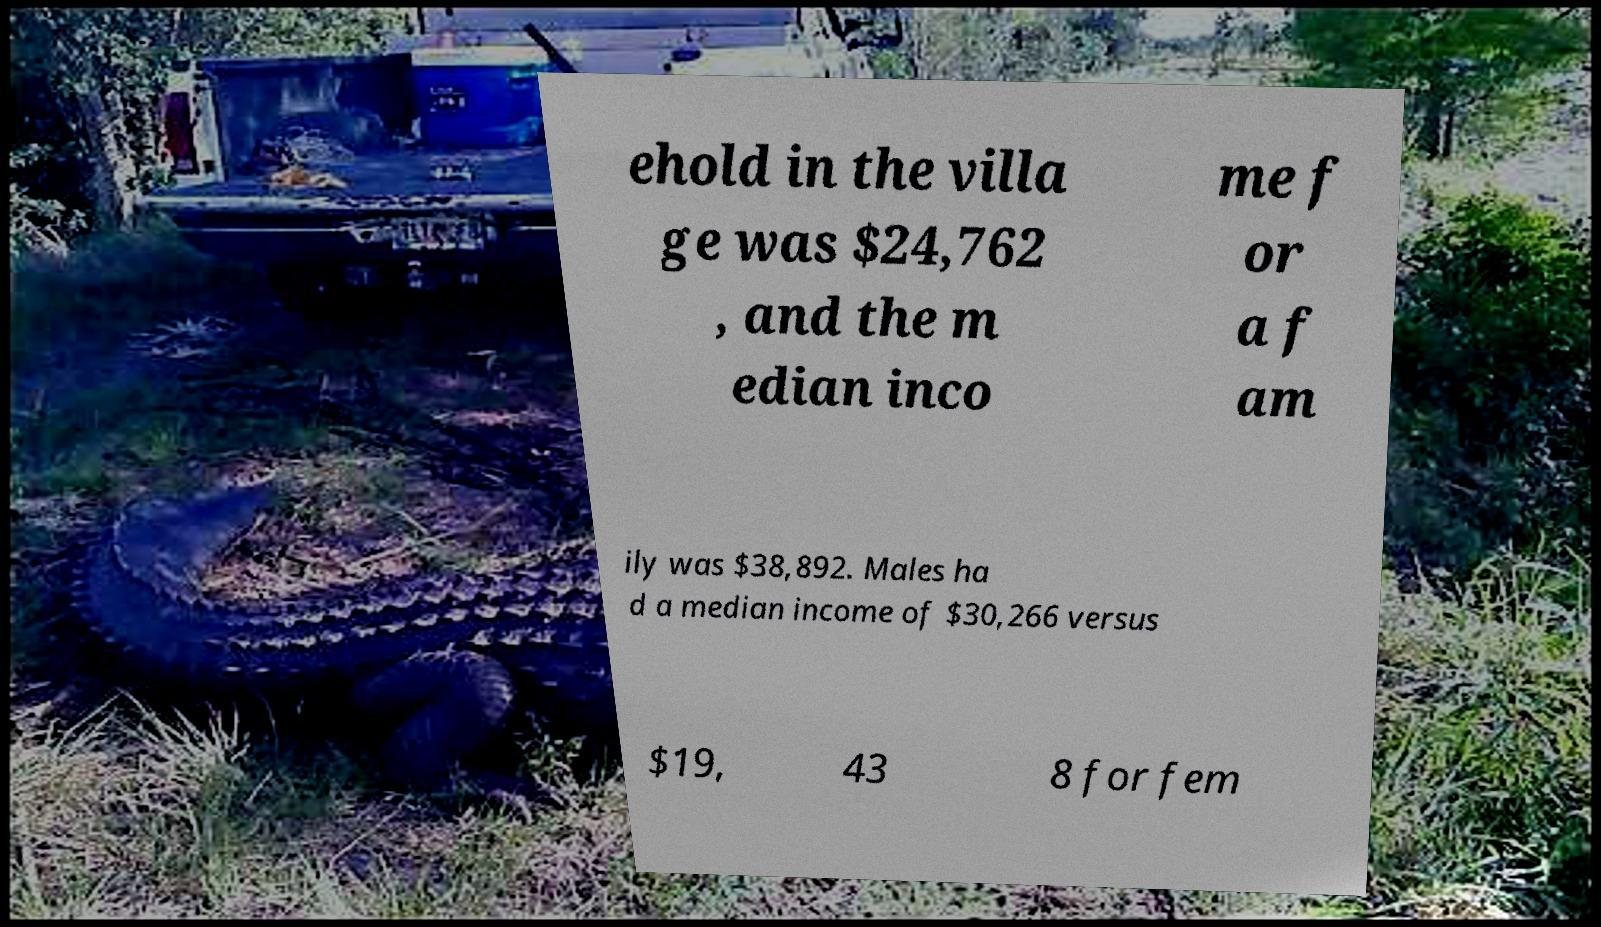Could you assist in decoding the text presented in this image and type it out clearly? ehold in the villa ge was $24,762 , and the m edian inco me f or a f am ily was $38,892. Males ha d a median income of $30,266 versus $19, 43 8 for fem 